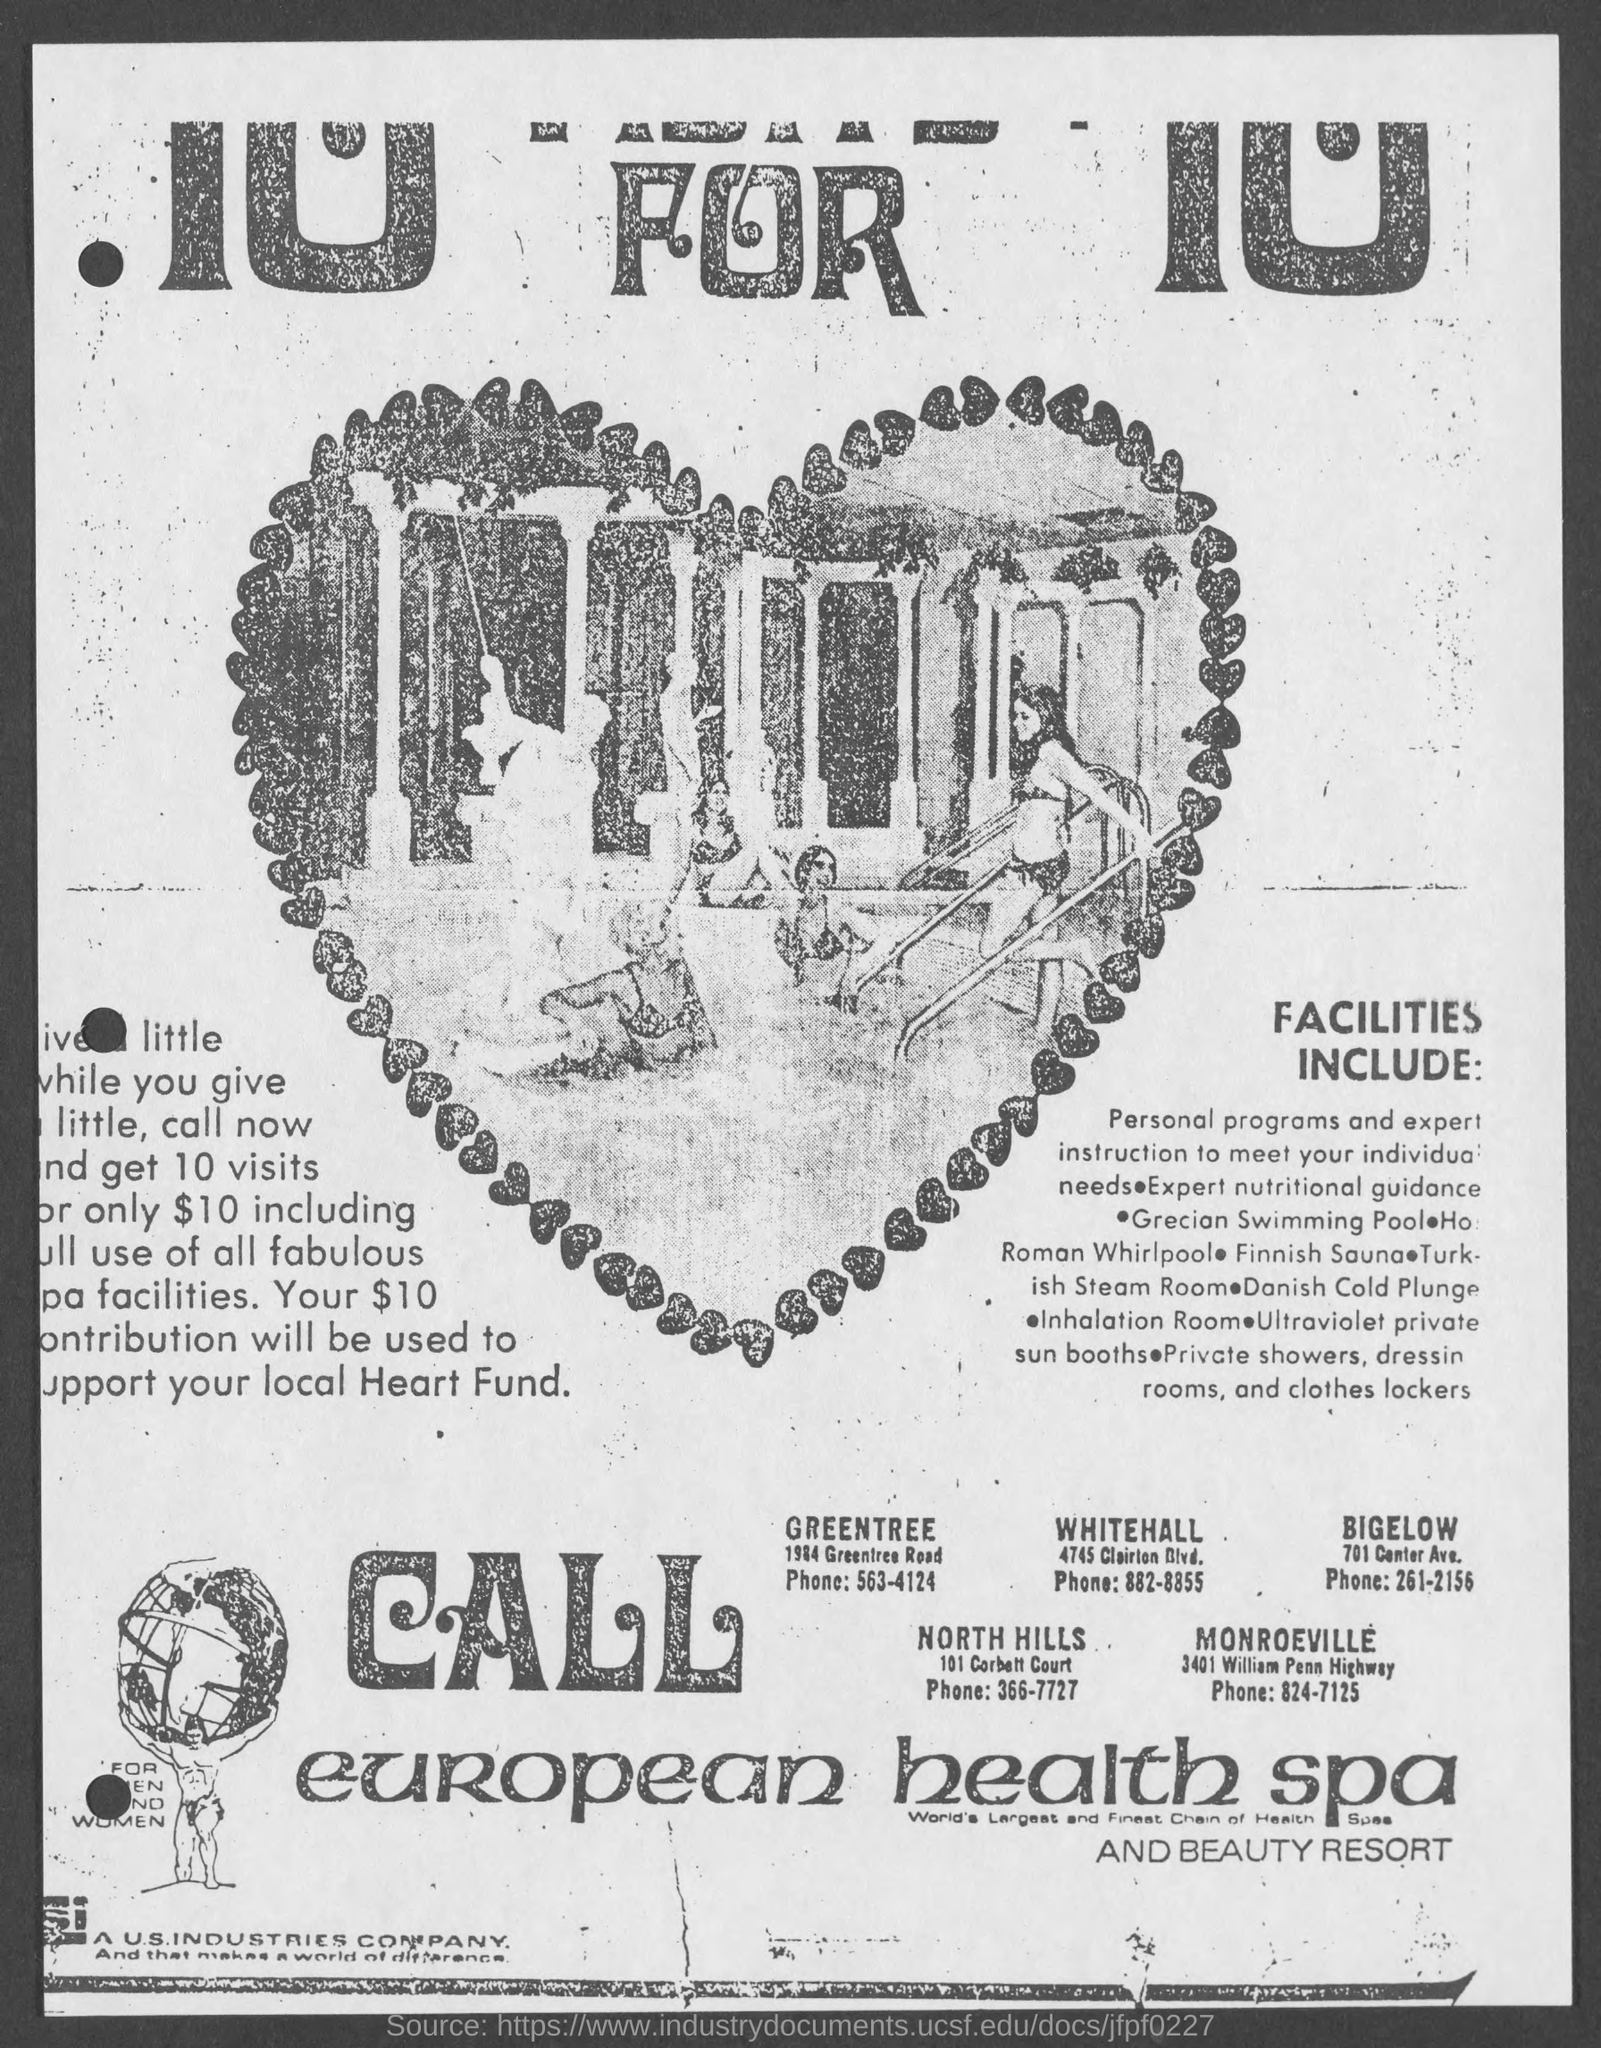Indicate a few pertinent items in this graphic. The phone number is 261-2156 for Bigelow. The phone number for Whitehall is 882-8855. The phone number for North Hills is 366-7727. The phone number for Monroeville is 824-7125. The phone number for Greentree is 563-4124. 